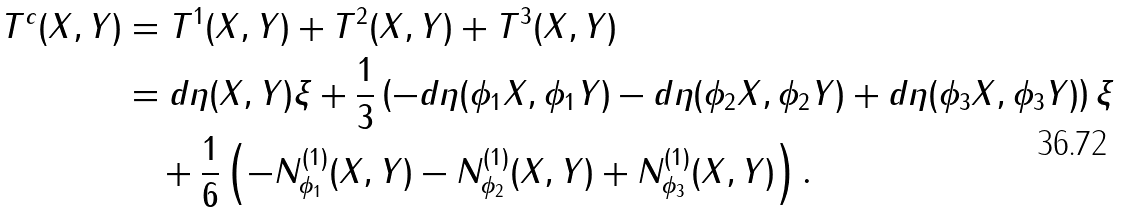<formula> <loc_0><loc_0><loc_500><loc_500>T ^ { c } ( X , Y ) & = T ^ { 1 } ( X , Y ) + T ^ { 2 } ( X , Y ) + T ^ { 3 } ( X , Y ) \\ & = d \eta ( X , Y ) \xi + \frac { 1 } { 3 } \left ( - d \eta ( \phi _ { 1 } X , \phi _ { 1 } Y ) - d \eta ( \phi _ { 2 } X , \phi _ { 2 } Y ) + d \eta ( \phi _ { 3 } X , \phi _ { 3 } Y ) \right ) \xi \\ & \quad + \frac { 1 } { 6 } \left ( - N ^ { ( 1 ) } _ { \phi _ { 1 } } ( X , Y ) - N ^ { ( 1 ) } _ { \phi _ { 2 } } ( X , Y ) + N ^ { ( 1 ) } _ { \phi _ { 3 } } ( X , Y ) \right ) .</formula> 